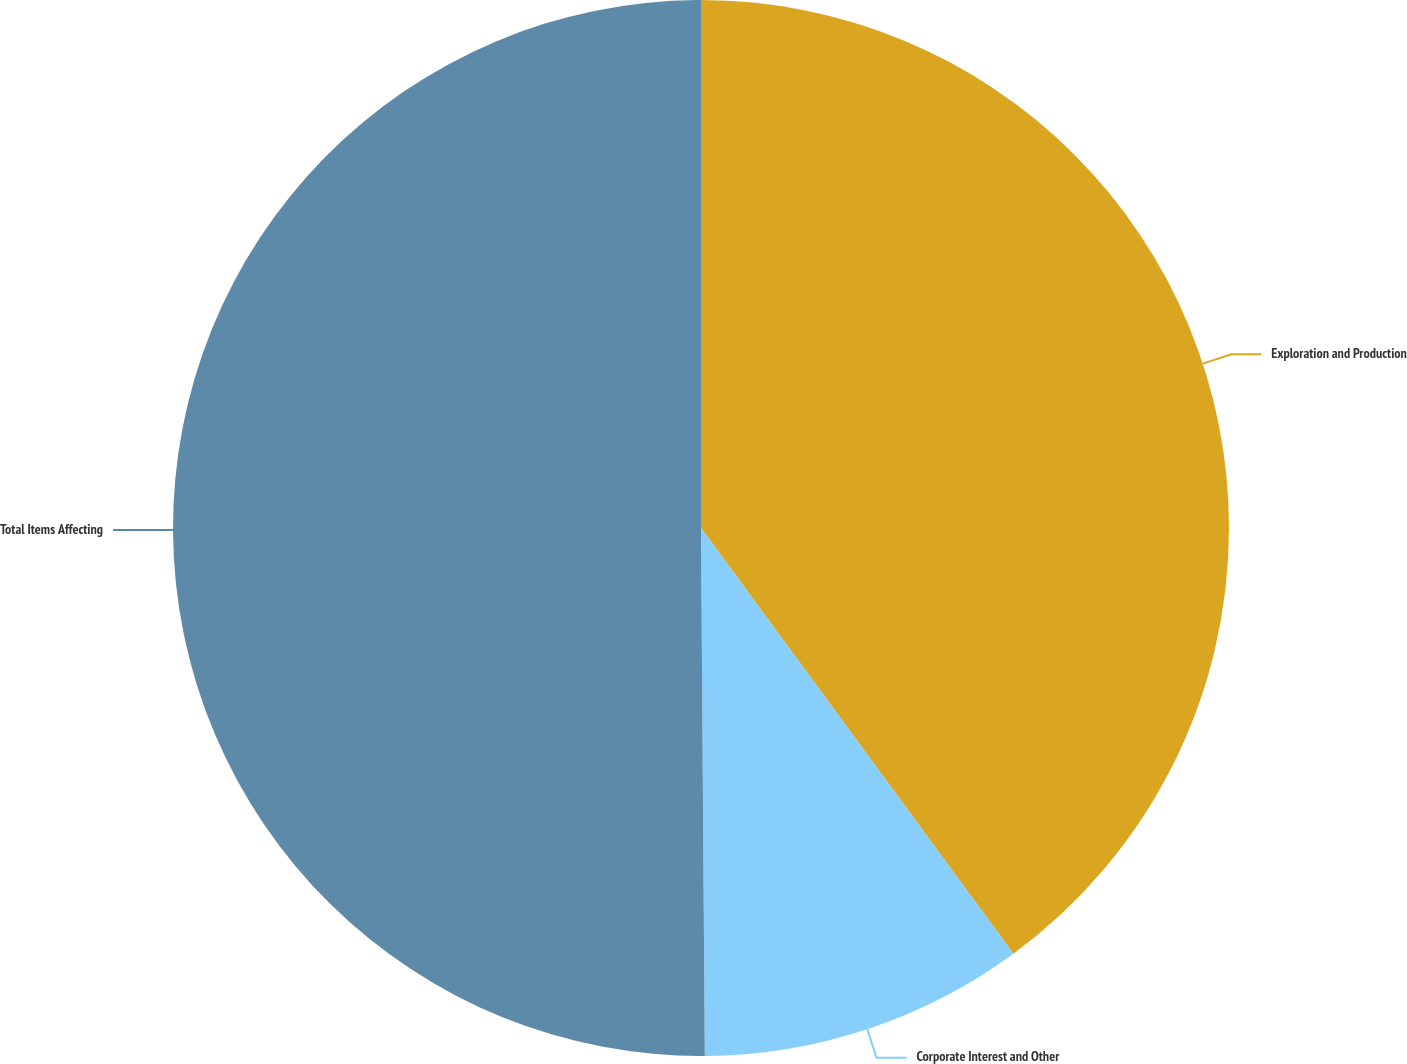Convert chart to OTSL. <chart><loc_0><loc_0><loc_500><loc_500><pie_chart><fcel>Exploration and Production<fcel>Corporate Interest and Other<fcel>Total Items Affecting<nl><fcel>39.92%<fcel>9.96%<fcel>50.11%<nl></chart> 